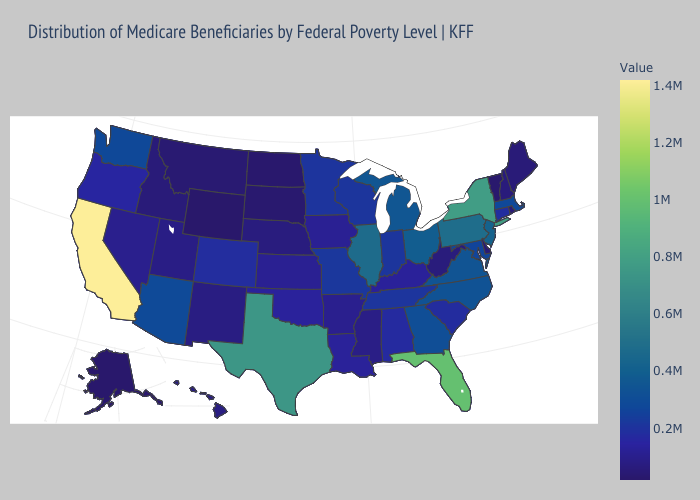Does the map have missing data?
Write a very short answer. No. Does the map have missing data?
Write a very short answer. No. Among the states that border Minnesota , does North Dakota have the highest value?
Write a very short answer. No. Is the legend a continuous bar?
Write a very short answer. Yes. Does the map have missing data?
Quick response, please. No. Among the states that border Michigan , which have the highest value?
Write a very short answer. Ohio. Does New Jersey have the highest value in the Northeast?
Be succinct. No. 